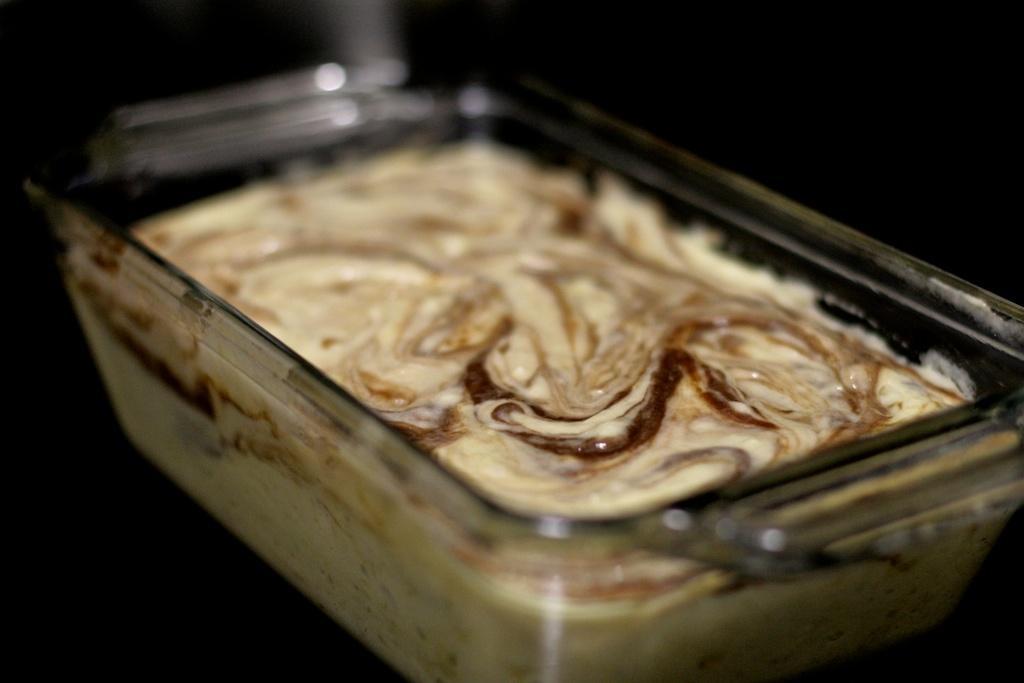Describe this image in one or two sentences. In the picture I can see a food item in a glass bowl. 